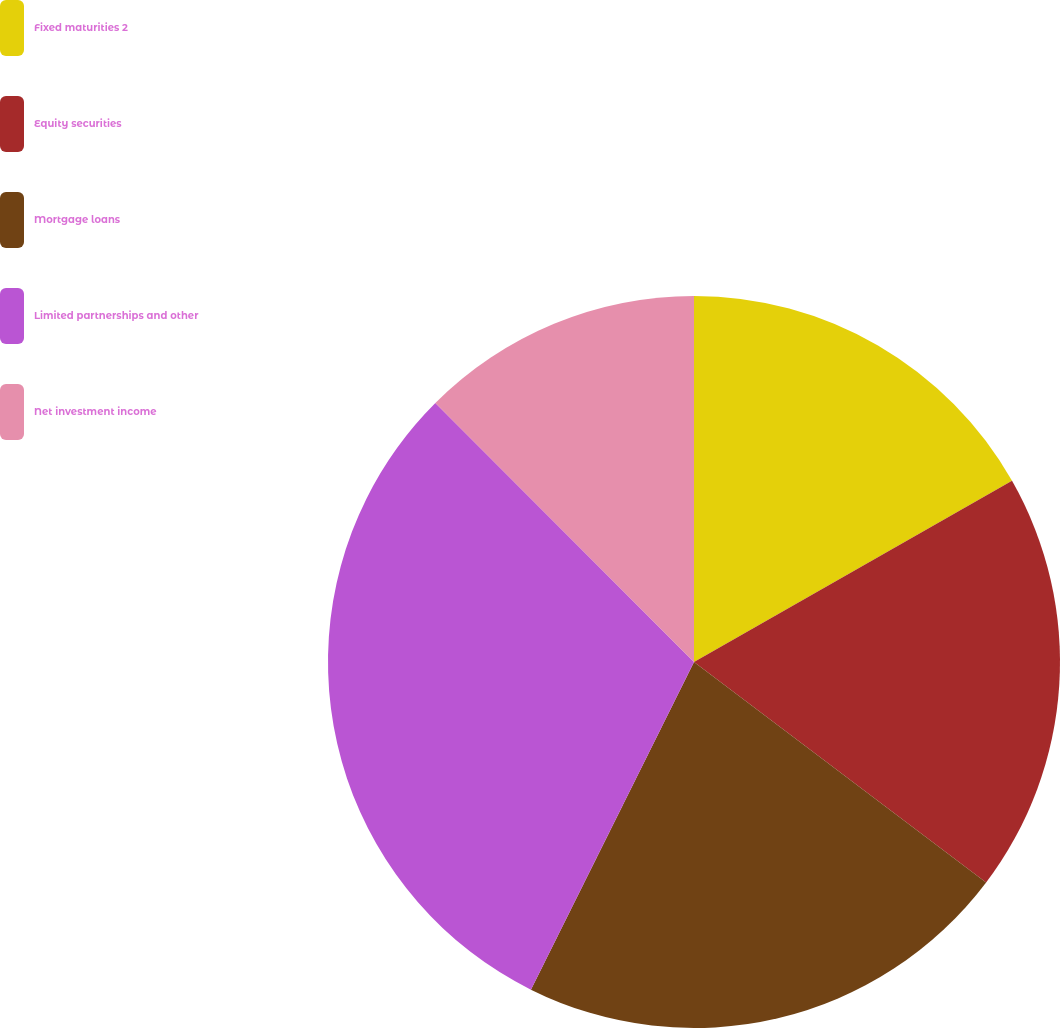Convert chart to OTSL. <chart><loc_0><loc_0><loc_500><loc_500><pie_chart><fcel>Fixed maturities 2<fcel>Equity securities<fcel>Mortgage loans<fcel>Limited partnerships and other<fcel>Net investment income<nl><fcel>16.76%<fcel>18.53%<fcel>22.06%<fcel>30.16%<fcel>12.49%<nl></chart> 